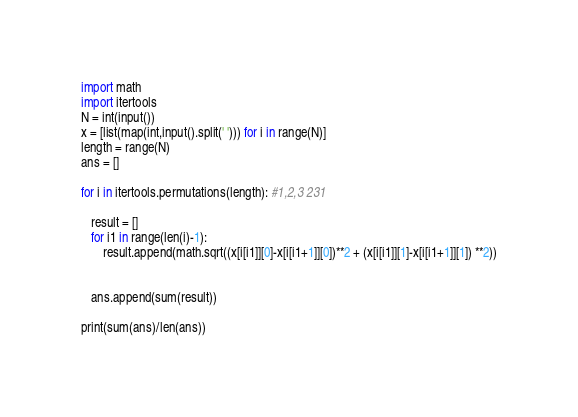Convert code to text. <code><loc_0><loc_0><loc_500><loc_500><_Python_>import math
import itertools
N = int(input())
x = [list(map(int,input().split(' '))) for i in range(N)]
length = range(N)
ans = []

for i in itertools.permutations(length): #1,2,3 231

   result = []
   for i1 in range(len(i)-1):
       result.append(math.sqrt((x[i[i1]][0]-x[i[i1+1]][0])**2 + (x[i[i1]][1]-x[i[i1+1]][1]) **2))


   ans.append(sum(result))

print(sum(ans)/len(ans))
</code> 